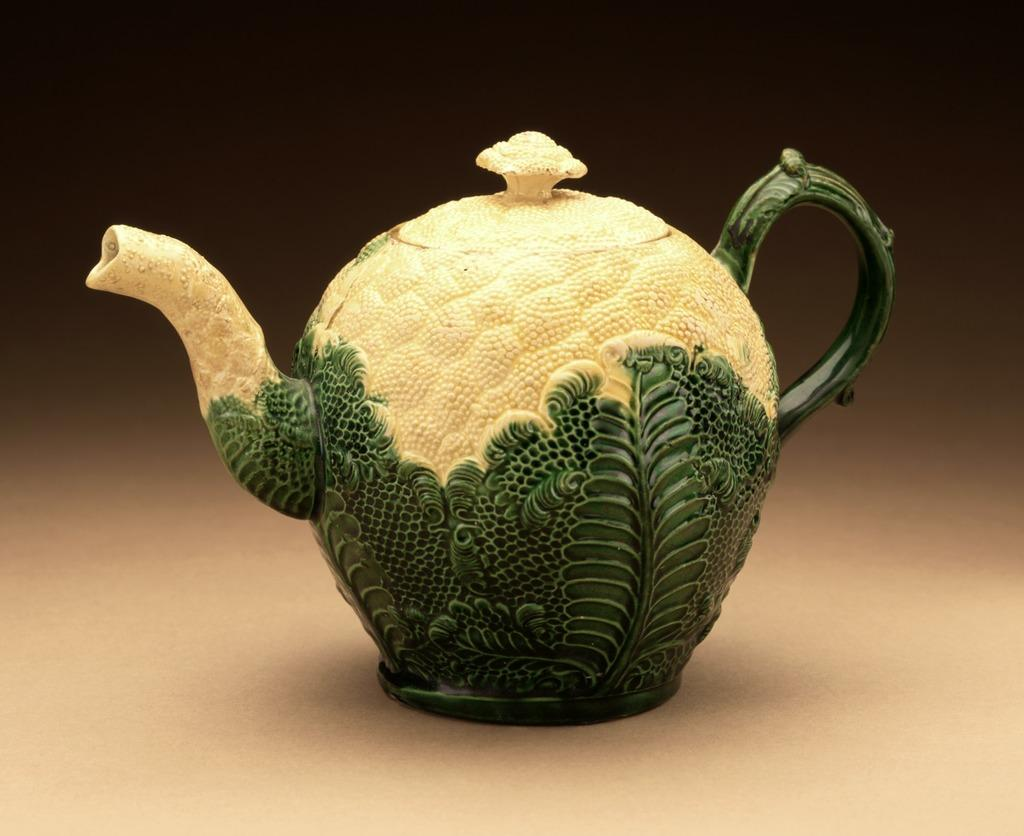What is the main object in the image? There is a tea jug in the image. What feature does the tea jug have? The tea jug has a lid. Where is the tea jug located in the image? The tea jug is placed on a surface. What type of feast is being prepared with the tea jug in the image? There is no indication of a feast or any food preparation in the image; it only features a tea jug with a lid. Can you describe the ray that is illuminating the tea jug in the image? There is no ray present in the image; it only features a tea jug with a lid. 